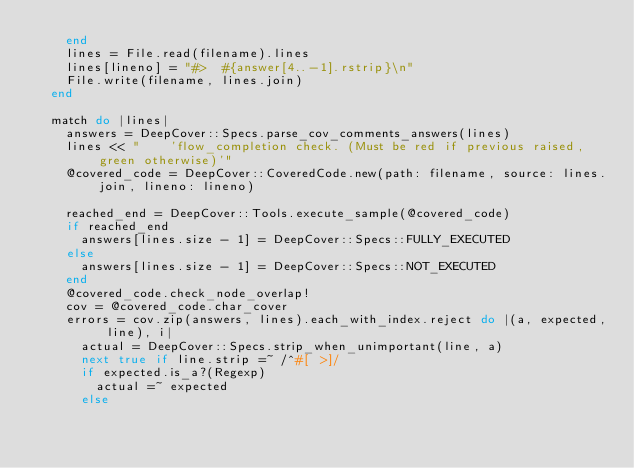Convert code to text. <code><loc_0><loc_0><loc_500><loc_500><_Ruby_>    end
    lines = File.read(filename).lines
    lines[lineno] = "#>  #{answer[4..-1].rstrip}\n"
    File.write(filename, lines.join)
  end

  match do |lines|
    answers = DeepCover::Specs.parse_cov_comments_answers(lines)
    lines << "    'flow_completion check. (Must be red if previous raised, green otherwise)'"
    @covered_code = DeepCover::CoveredCode.new(path: filename, source: lines.join, lineno: lineno)

    reached_end = DeepCover::Tools.execute_sample(@covered_code)
    if reached_end
      answers[lines.size - 1] = DeepCover::Specs::FULLY_EXECUTED
    else
      answers[lines.size - 1] = DeepCover::Specs::NOT_EXECUTED
    end
    @covered_code.check_node_overlap!
    cov = @covered_code.char_cover
    errors = cov.zip(answers, lines).each_with_index.reject do |(a, expected, line), i|
      actual = DeepCover::Specs.strip_when_unimportant(line, a)
      next true if line.strip =~ /^#[ >]/
      if expected.is_a?(Regexp)
        actual =~ expected
      else</code> 